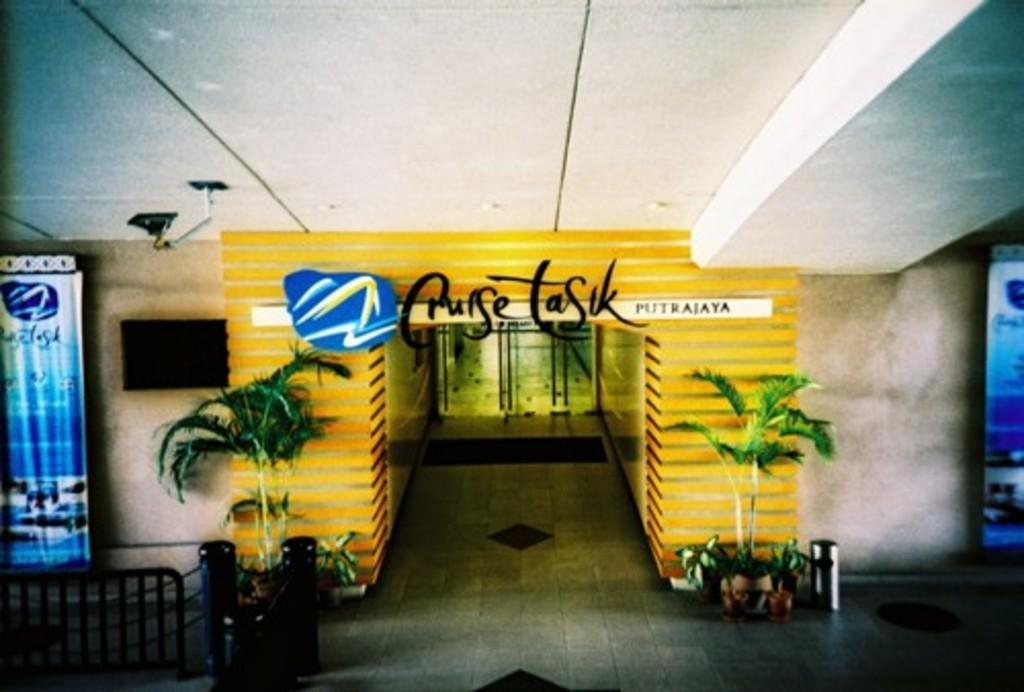<image>
Provide a brief description of the given image. Cruise Tasuk is in black lettering on a yellow wall. 